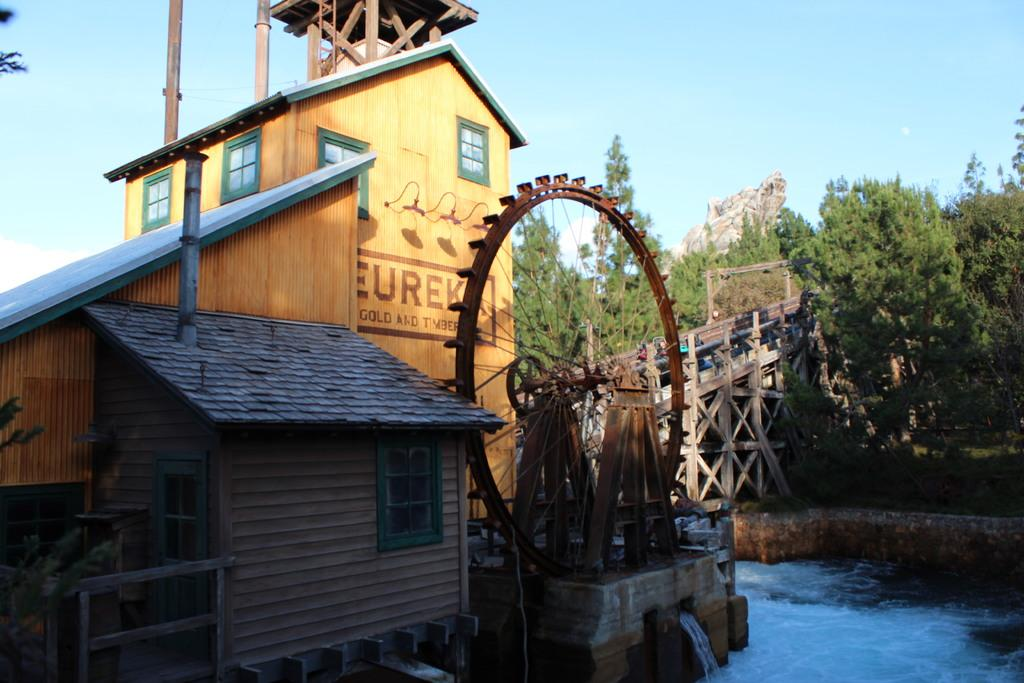What type of structure can be seen in the image? There is a building in the image. What is the circular object in the image used for? The circular object in the image is a machine, and water is flowing from it. What is the purpose of the circular machine in the image? The purpose of the circular machine in the image is to distribute water. What type of architectural feature is present in the image? There is a bridge in the image. What type of vegetation is present in the image? Trees are present in the image. What type of wood is used to construct the money in the image? There is no money present in the image, and therefore no wood is used to construct it. 